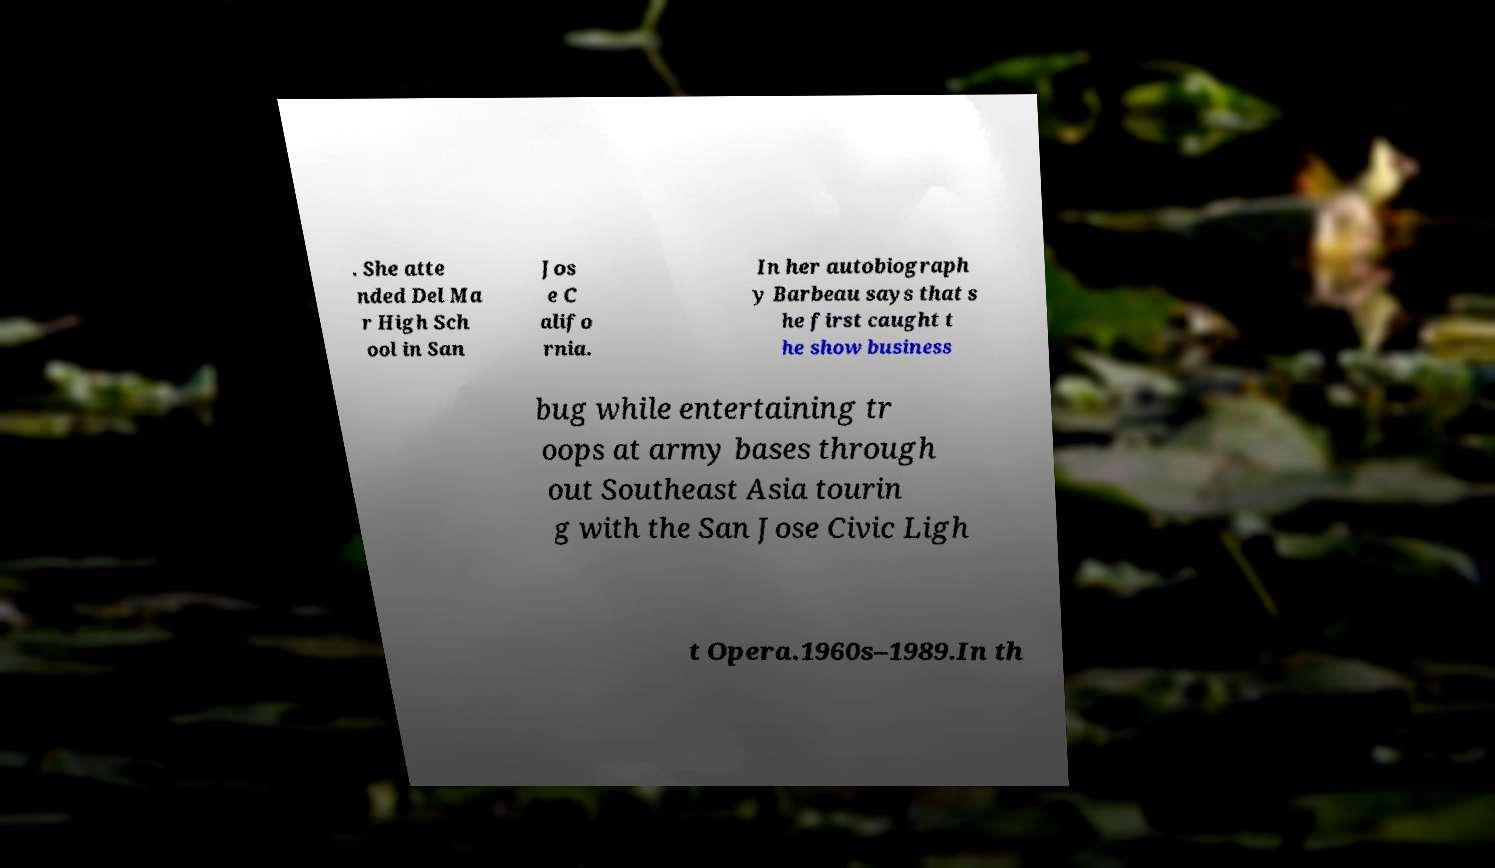Could you assist in decoding the text presented in this image and type it out clearly? . She atte nded Del Ma r High Sch ool in San Jos e C alifo rnia. In her autobiograph y Barbeau says that s he first caught t he show business bug while entertaining tr oops at army bases through out Southeast Asia tourin g with the San Jose Civic Ligh t Opera.1960s–1989.In th 